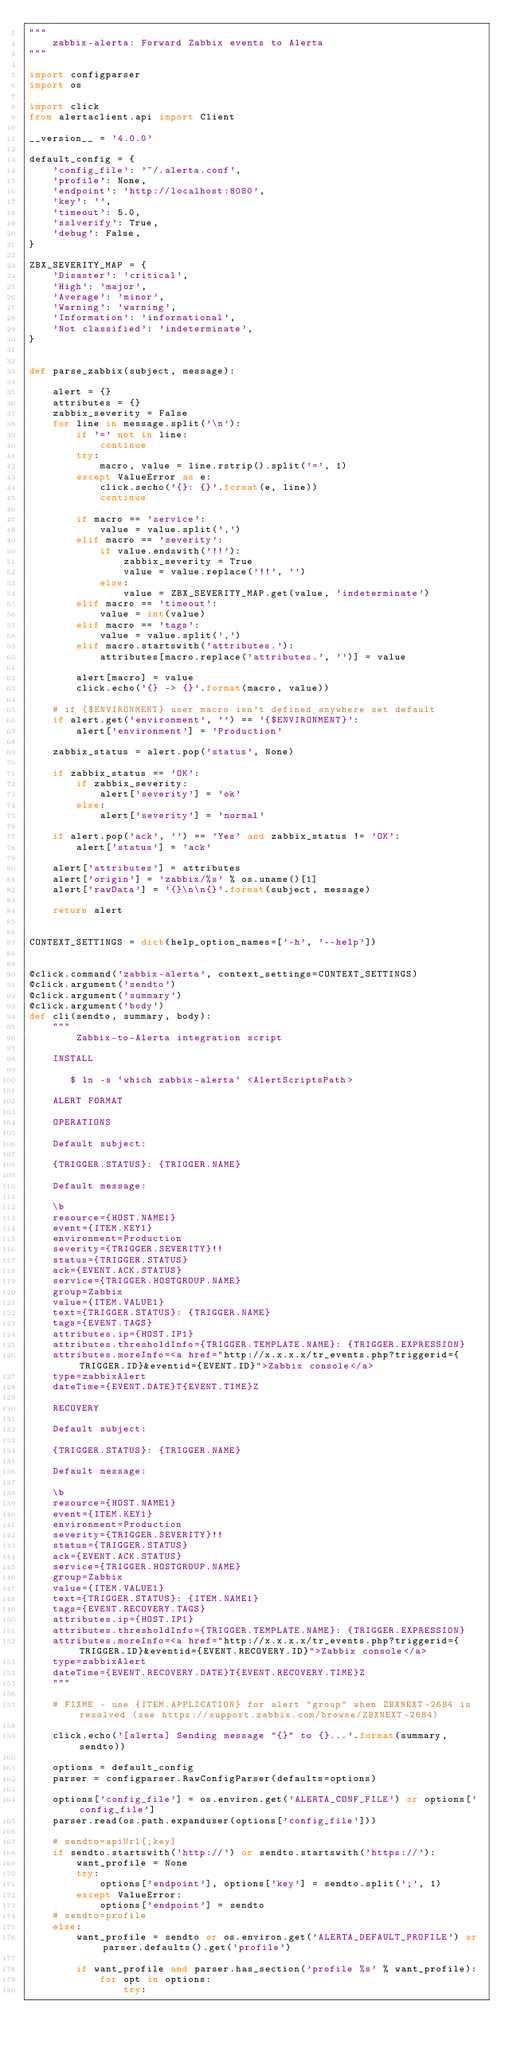<code> <loc_0><loc_0><loc_500><loc_500><_Python_>"""
    zabbix-alerta: Forward Zabbix events to Alerta
"""

import configparser
import os

import click
from alertaclient.api import Client

__version__ = '4.0.0'

default_config = {
    'config_file': '~/.alerta.conf',
    'profile': None,
    'endpoint': 'http://localhost:8080',
    'key': '',
    'timeout': 5.0,
    'sslverify': True,
    'debug': False,
}

ZBX_SEVERITY_MAP = {
    'Disaster': 'critical',
    'High': 'major',
    'Average': 'minor',
    'Warning': 'warning',
    'Information': 'informational',
    'Not classified': 'indeterminate',
}


def parse_zabbix(subject, message):

    alert = {}
    attributes = {}
    zabbix_severity = False
    for line in message.split('\n'):
        if '=' not in line:
            continue
        try:
            macro, value = line.rstrip().split('=', 1)
        except ValueError as e:
            click.secho('{}: {}'.format(e, line))
            continue

        if macro == 'service':
            value = value.split(',')
        elif macro == 'severity':
            if value.endswith('!!'):
                zabbix_severity = True
                value = value.replace('!!', '')
            else:
                value = ZBX_SEVERITY_MAP.get(value, 'indeterminate')
        elif macro == 'timeout':
            value = int(value)
        elif macro == 'tags':
            value = value.split(',')
        elif macro.startswith('attributes.'):
            attributes[macro.replace('attributes.', '')] = value

        alert[macro] = value
        click.echo('{} -> {}'.format(macro, value))

    # if {$ENVIRONMENT} user macro isn't defined anywhere set default
    if alert.get('environment', '') == '{$ENVIRONMENT}':
        alert['environment'] = 'Production'

    zabbix_status = alert.pop('status', None)

    if zabbix_status == 'OK':
        if zabbix_severity:
            alert['severity'] = 'ok'
        else:
            alert['severity'] = 'normal'

    if alert.pop('ack', '') == 'Yes' and zabbix_status != 'OK':
        alert['status'] = 'ack'

    alert['attributes'] = attributes
    alert['origin'] = 'zabbix/%s' % os.uname()[1]
    alert['rawData'] = '{}\n\n{}'.format(subject, message)

    return alert


CONTEXT_SETTINGS = dict(help_option_names=['-h', '--help'])


@click.command('zabbix-alerta', context_settings=CONTEXT_SETTINGS)
@click.argument('sendto')
@click.argument('summary')
@click.argument('body')
def cli(sendto, summary, body):
    """
        Zabbix-to-Alerta integration script

    INSTALL

       $ ln -s `which zabbix-alerta` <AlertScriptsPath>

    ALERT FORMAT

    OPERATIONS

    Default subject:

    {TRIGGER.STATUS}: {TRIGGER.NAME}

    Default message:

    \b
    resource={HOST.NAME1}
    event={ITEM.KEY1}
    environment=Production
    severity={TRIGGER.SEVERITY}!!
    status={TRIGGER.STATUS}
    ack={EVENT.ACK.STATUS}
    service={TRIGGER.HOSTGROUP.NAME}
    group=Zabbix
    value={ITEM.VALUE1}
    text={TRIGGER.STATUS}: {TRIGGER.NAME}
    tags={EVENT.TAGS}
    attributes.ip={HOST.IP1}
    attributes.thresholdInfo={TRIGGER.TEMPLATE.NAME}: {TRIGGER.EXPRESSION}
    attributes.moreInfo=<a href="http://x.x.x.x/tr_events.php?triggerid={TRIGGER.ID}&eventid={EVENT.ID}">Zabbix console</a>
    type=zabbixAlert
    dateTime={EVENT.DATE}T{EVENT.TIME}Z

    RECOVERY

    Default subject:

    {TRIGGER.STATUS}: {TRIGGER.NAME}

    Default message:

    \b
    resource={HOST.NAME1}
    event={ITEM.KEY1}
    environment=Production
    severity={TRIGGER.SEVERITY}!!
    status={TRIGGER.STATUS}
    ack={EVENT.ACK.STATUS}
    service={TRIGGER.HOSTGROUP.NAME}
    group=Zabbix
    value={ITEM.VALUE1}
    text={TRIGGER.STATUS}: {ITEM.NAME1}
    tags={EVENT.RECOVERY.TAGS}
    attributes.ip={HOST.IP1}
    attributes.thresholdInfo={TRIGGER.TEMPLATE.NAME}: {TRIGGER.EXPRESSION}
    attributes.moreInfo=<a href="http://x.x.x.x/tr_events.php?triggerid={TRIGGER.ID}&eventid={EVENT.RECOVERY.ID}">Zabbix console</a>
    type=zabbixAlert
    dateTime={EVENT.RECOVERY.DATE}T{EVENT.RECOVERY.TIME}Z
    """

    # FIXME - use {ITEM.APPLICATION} for alert "group" when ZBXNEXT-2684 is resolved (see https://support.zabbix.com/browse/ZBXNEXT-2684)

    click.echo('[alerta] Sending message "{}" to {}...'.format(summary, sendto))

    options = default_config
    parser = configparser.RawConfigParser(defaults=options)

    options['config_file'] = os.environ.get('ALERTA_CONF_FILE') or options['config_file']
    parser.read(os.path.expanduser(options['config_file']))

    # sendto=apiUrl[;key]
    if sendto.startswith('http://') or sendto.startswith('https://'):
        want_profile = None
        try:
            options['endpoint'], options['key'] = sendto.split(';', 1)
        except ValueError:
            options['endpoint'] = sendto
    # sendto=profile
    else:
        want_profile = sendto or os.environ.get('ALERTA_DEFAULT_PROFILE') or parser.defaults().get('profile')

        if want_profile and parser.has_section('profile %s' % want_profile):
            for opt in options:
                try:</code> 